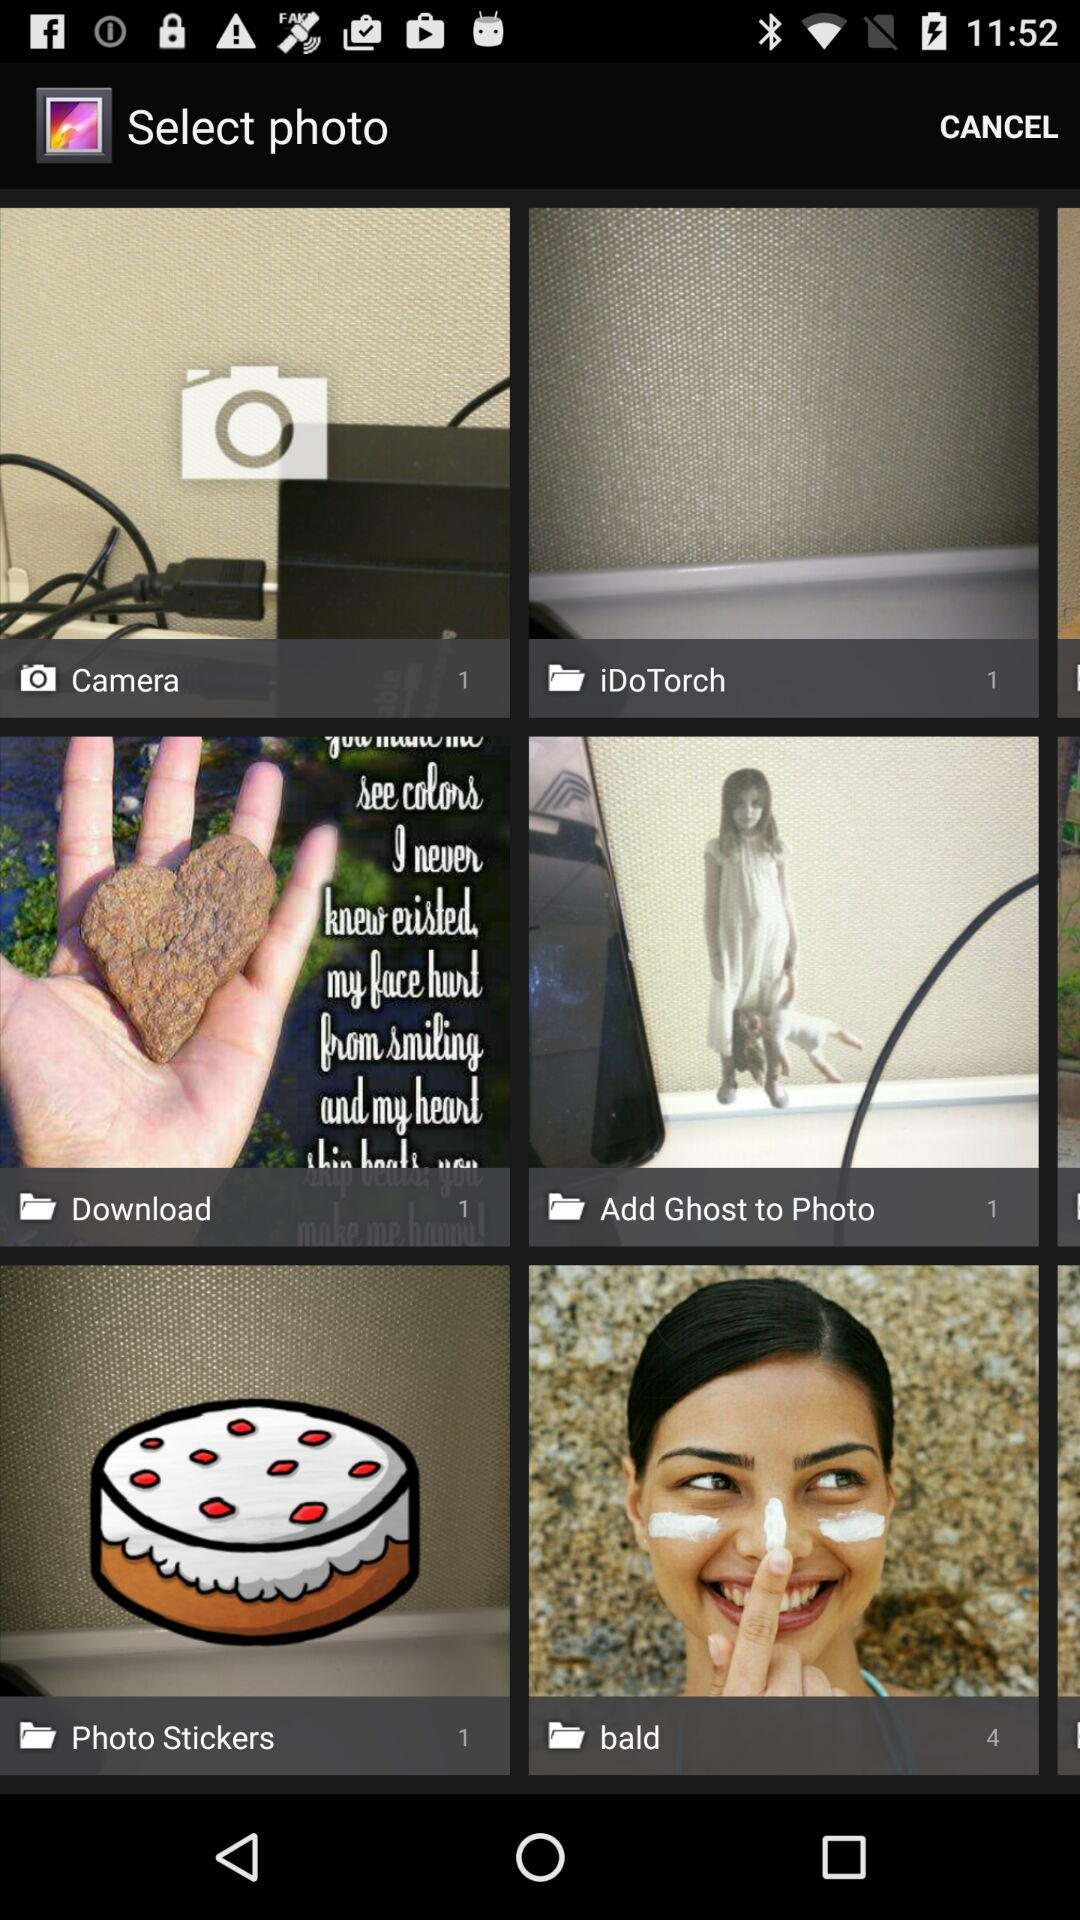How many files are in the "Download" folder? There is 1 file in the "Download" folder. 